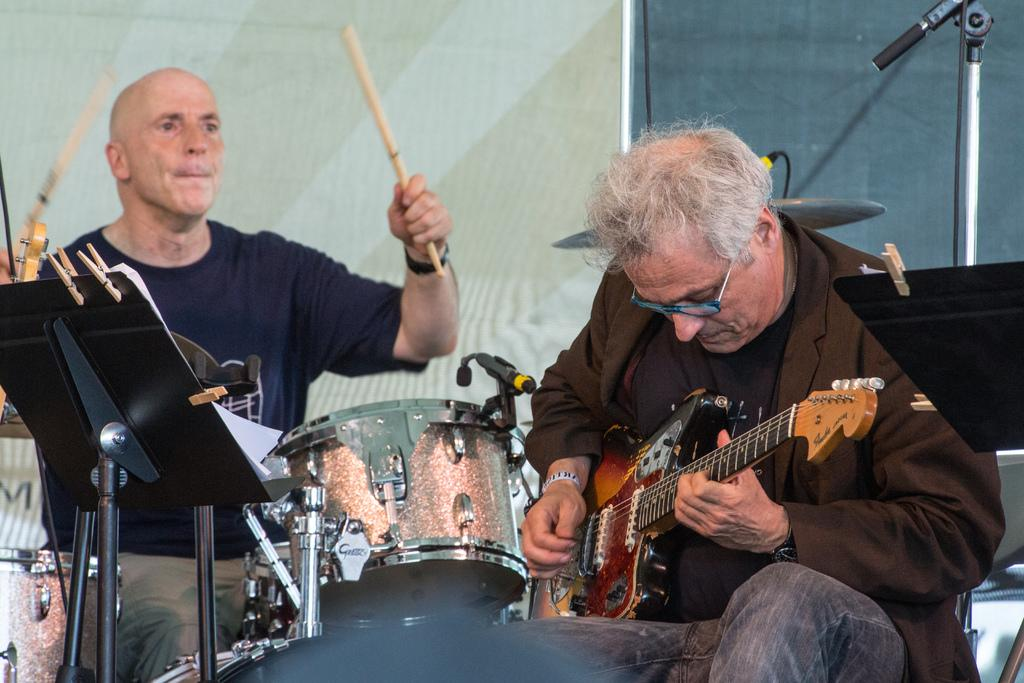How many people are in the image? There are two persons in the image. What are the two persons doing in the image? The two persons are sitting and playing musical instruments. Where are the musical instruments located in relation to the persons? The musical instruments are in front of them. What can be seen in the background of the image? There is a wall and a stand in the background of the image. What type of calculator can be seen on the stand in the image? There is no calculator present in the image; only a wall and a stand are visible in the background. How many pies are being served by the persons in the image? There are no pies present in the image; the two persons are playing musical instruments. 